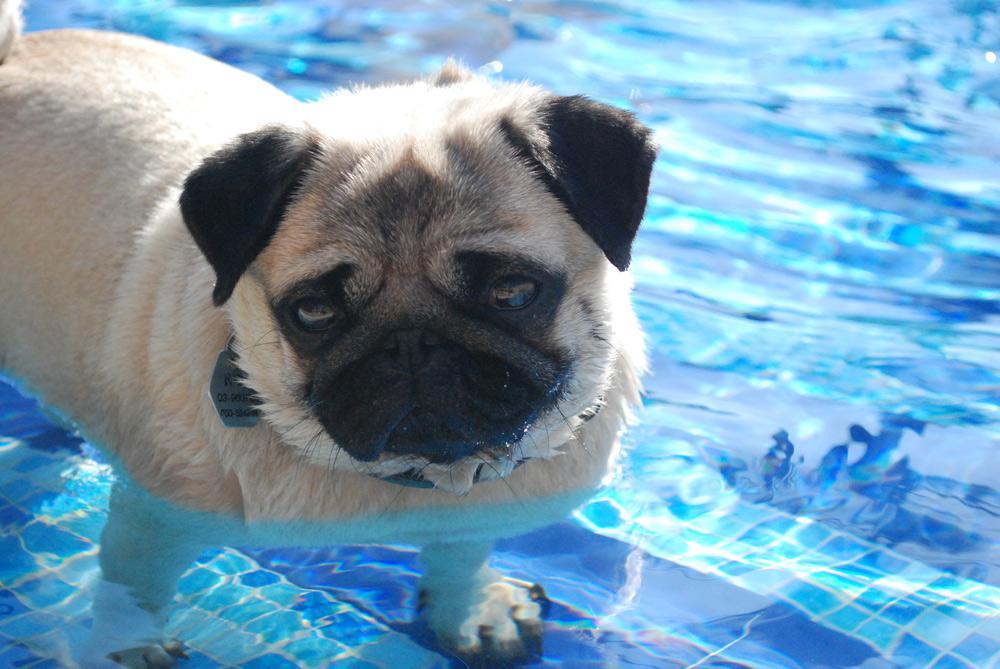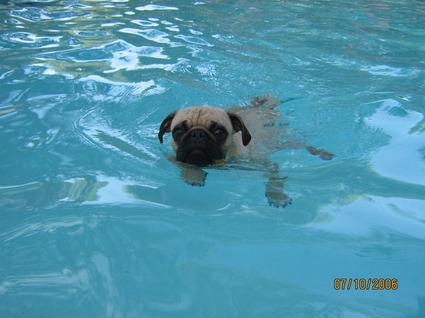The first image is the image on the left, the second image is the image on the right. Evaluate the accuracy of this statement regarding the images: "A pug wearing a yellowish life vest swims toward the camera.". Is it true? Answer yes or no. No. 